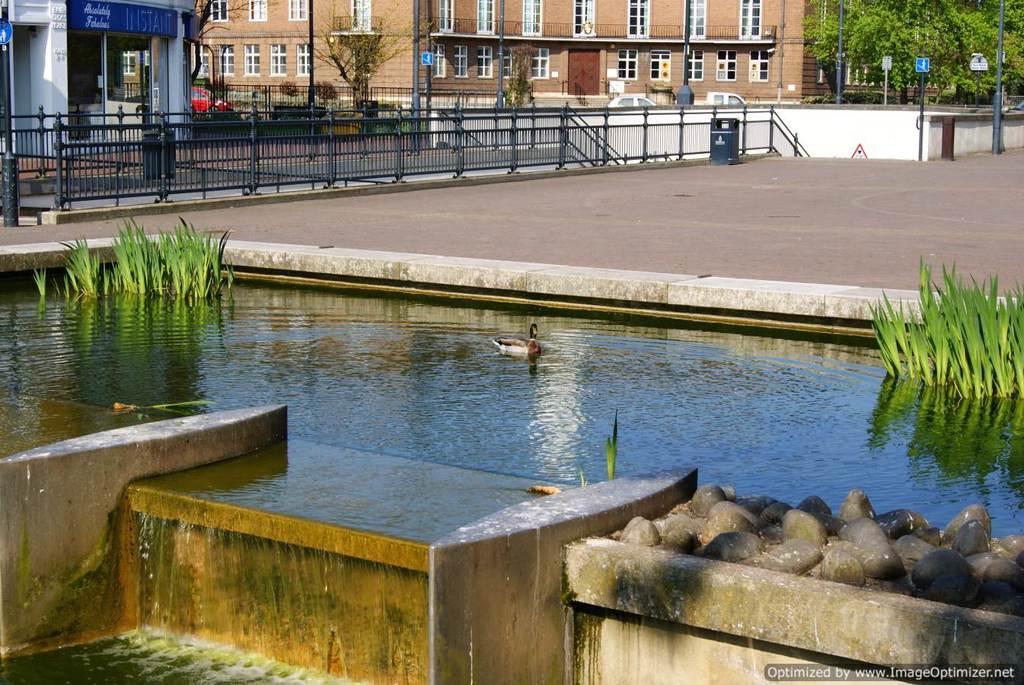In one or two sentences, can you explain what this image depicts? In the image in the center, we can see water, plants and one bird. In the background, we can see trees, buildings, windows, poles, fences, sign boards, vehicles etc. 